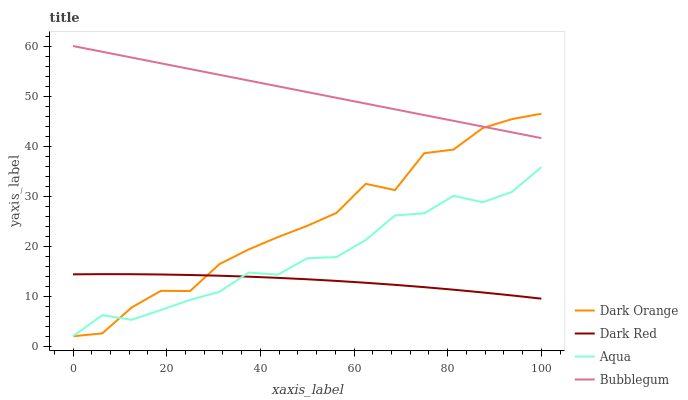Does Dark Red have the minimum area under the curve?
Answer yes or no. Yes. Does Bubblegum have the maximum area under the curve?
Answer yes or no. Yes. Does Aqua have the minimum area under the curve?
Answer yes or no. No. Does Aqua have the maximum area under the curve?
Answer yes or no. No. Is Bubblegum the smoothest?
Answer yes or no. Yes. Is Dark Orange the roughest?
Answer yes or no. Yes. Is Aqua the smoothest?
Answer yes or no. No. Is Aqua the roughest?
Answer yes or no. No. Does Dark Orange have the lowest value?
Answer yes or no. Yes. Does Bubblegum have the lowest value?
Answer yes or no. No. Does Bubblegum have the highest value?
Answer yes or no. Yes. Does Aqua have the highest value?
Answer yes or no. No. Is Dark Red less than Bubblegum?
Answer yes or no. Yes. Is Bubblegum greater than Aqua?
Answer yes or no. Yes. Does Dark Red intersect Dark Orange?
Answer yes or no. Yes. Is Dark Red less than Dark Orange?
Answer yes or no. No. Is Dark Red greater than Dark Orange?
Answer yes or no. No. Does Dark Red intersect Bubblegum?
Answer yes or no. No. 